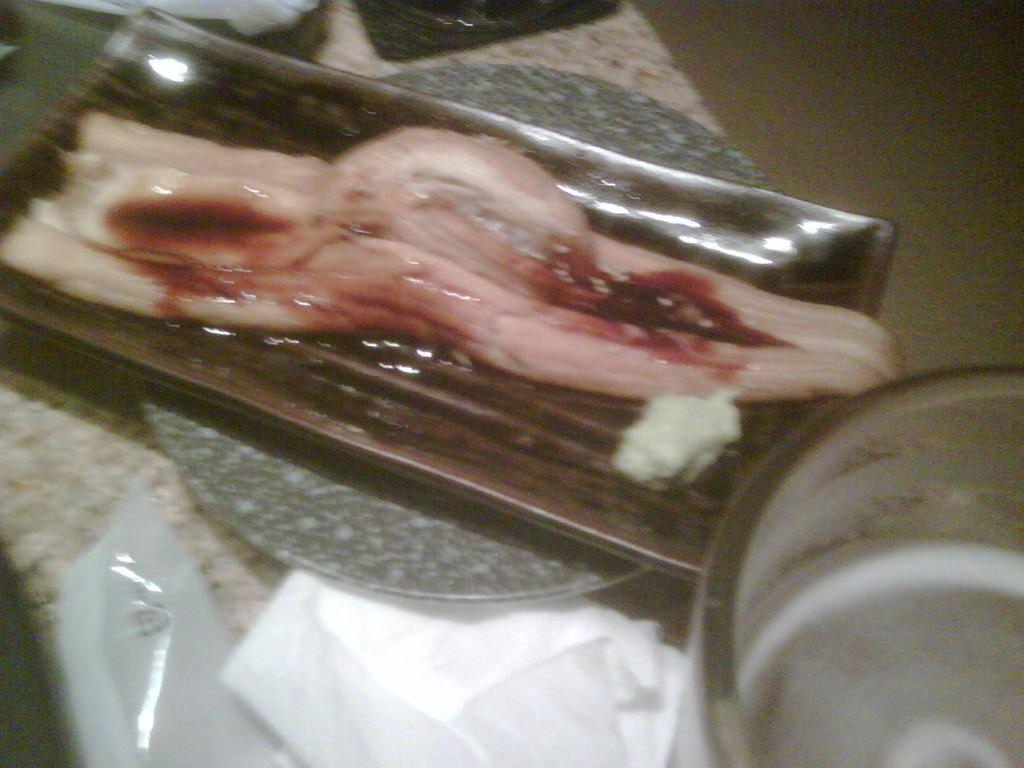What is on the plate in the image? There is a biological organ on a plate in the image. What can be observed on the organ? The organ has blood on it, and there is a mass on the organ. Where is the plate located? The plate is on a table. What else is on the table beside the plate? There are papers beside the plate on the table. What is the best route to take to win the game in the image? There is no game present in the image, so it is not possible to determine the best route to win. 